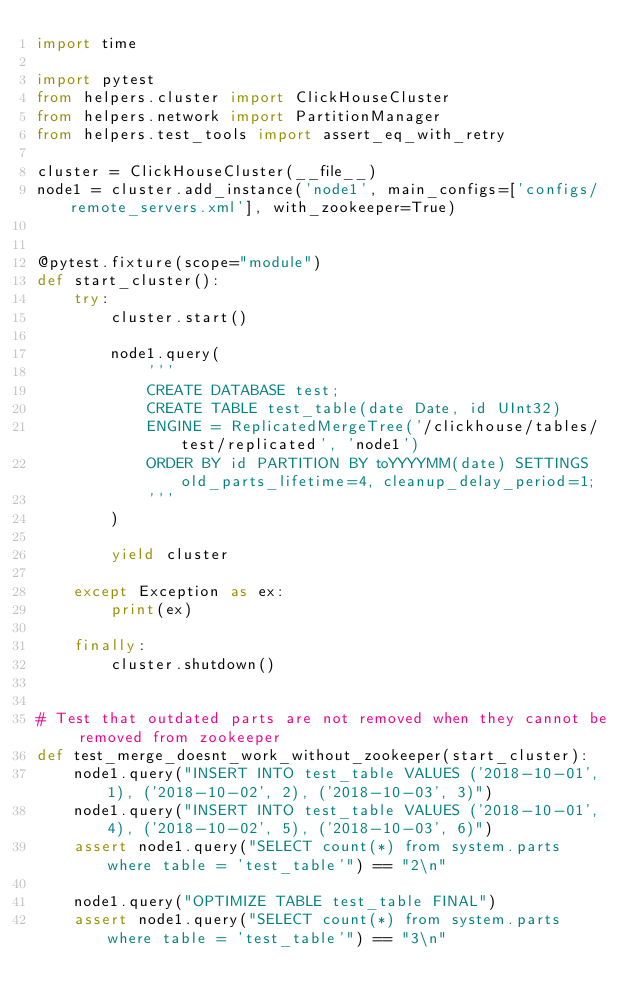Convert code to text. <code><loc_0><loc_0><loc_500><loc_500><_Python_>import time

import pytest
from helpers.cluster import ClickHouseCluster
from helpers.network import PartitionManager
from helpers.test_tools import assert_eq_with_retry

cluster = ClickHouseCluster(__file__)
node1 = cluster.add_instance('node1', main_configs=['configs/remote_servers.xml'], with_zookeeper=True)


@pytest.fixture(scope="module")
def start_cluster():
    try:
        cluster.start()

        node1.query(
            '''
            CREATE DATABASE test;
            CREATE TABLE test_table(date Date, id UInt32)
            ENGINE = ReplicatedMergeTree('/clickhouse/tables/test/replicated', 'node1')
            ORDER BY id PARTITION BY toYYYYMM(date) SETTINGS old_parts_lifetime=4, cleanup_delay_period=1;
            '''
        )

        yield cluster

    except Exception as ex:
        print(ex)

    finally:
        cluster.shutdown()


# Test that outdated parts are not removed when they cannot be removed from zookeeper
def test_merge_doesnt_work_without_zookeeper(start_cluster):
    node1.query("INSERT INTO test_table VALUES ('2018-10-01', 1), ('2018-10-02', 2), ('2018-10-03', 3)")
    node1.query("INSERT INTO test_table VALUES ('2018-10-01', 4), ('2018-10-02', 5), ('2018-10-03', 6)")
    assert node1.query("SELECT count(*) from system.parts where table = 'test_table'") == "2\n"

    node1.query("OPTIMIZE TABLE test_table FINAL")
    assert node1.query("SELECT count(*) from system.parts where table = 'test_table'") == "3\n"
</code> 